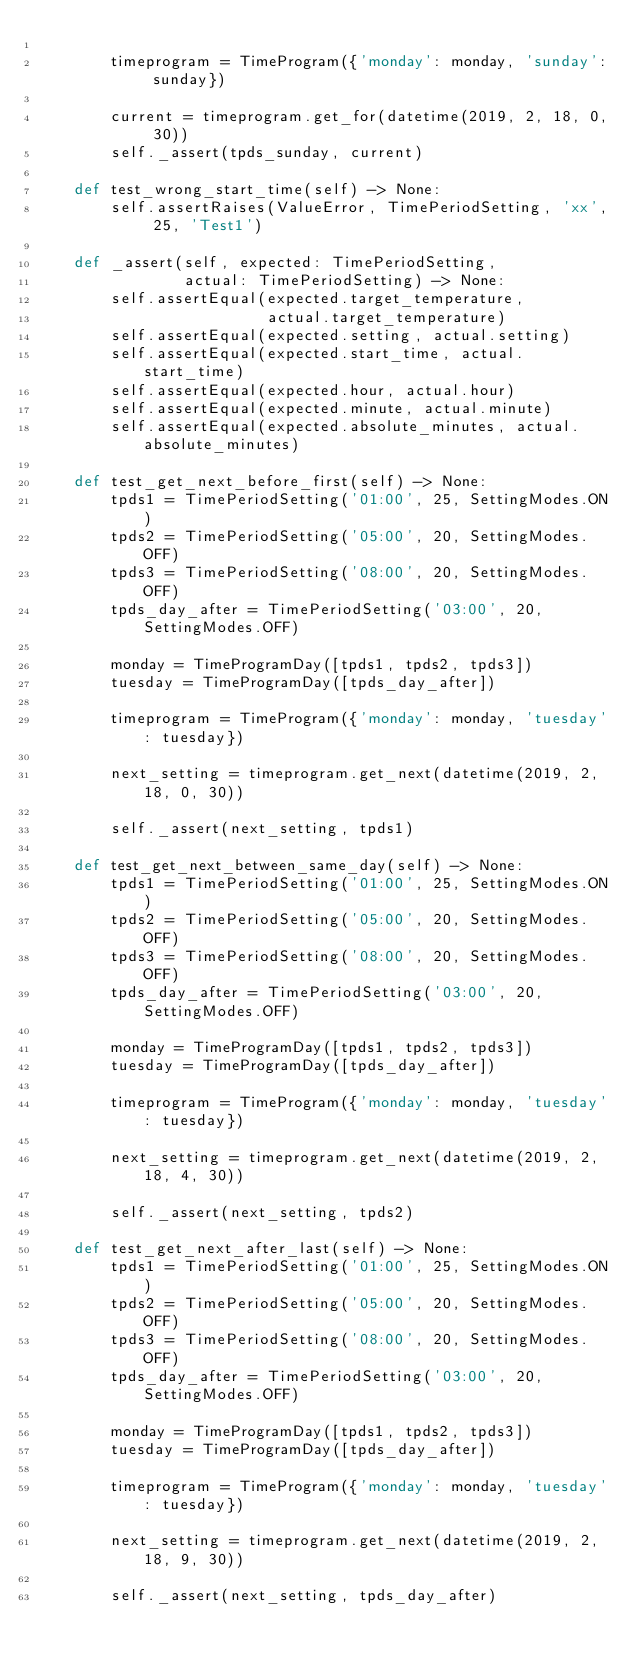Convert code to text. <code><loc_0><loc_0><loc_500><loc_500><_Python_>
        timeprogram = TimeProgram({'monday': monday, 'sunday': sunday})

        current = timeprogram.get_for(datetime(2019, 2, 18, 0, 30))
        self._assert(tpds_sunday, current)

    def test_wrong_start_time(self) -> None:
        self.assertRaises(ValueError, TimePeriodSetting, 'xx', 25, 'Test1')

    def _assert(self, expected: TimePeriodSetting,
                actual: TimePeriodSetting) -> None:
        self.assertEqual(expected.target_temperature,
                         actual.target_temperature)
        self.assertEqual(expected.setting, actual.setting)
        self.assertEqual(expected.start_time, actual.start_time)
        self.assertEqual(expected.hour, actual.hour)
        self.assertEqual(expected.minute, actual.minute)
        self.assertEqual(expected.absolute_minutes, actual.absolute_minutes)

    def test_get_next_before_first(self) -> None:
        tpds1 = TimePeriodSetting('01:00', 25, SettingModes.ON)
        tpds2 = TimePeriodSetting('05:00', 20, SettingModes.OFF)
        tpds3 = TimePeriodSetting('08:00', 20, SettingModes.OFF)
        tpds_day_after = TimePeriodSetting('03:00', 20, SettingModes.OFF)

        monday = TimeProgramDay([tpds1, tpds2, tpds3])
        tuesday = TimeProgramDay([tpds_day_after])

        timeprogram = TimeProgram({'monday': monday, 'tuesday': tuesday})

        next_setting = timeprogram.get_next(datetime(2019, 2, 18, 0, 30))

        self._assert(next_setting, tpds1)

    def test_get_next_between_same_day(self) -> None:
        tpds1 = TimePeriodSetting('01:00', 25, SettingModes.ON)
        tpds2 = TimePeriodSetting('05:00', 20, SettingModes.OFF)
        tpds3 = TimePeriodSetting('08:00', 20, SettingModes.OFF)
        tpds_day_after = TimePeriodSetting('03:00', 20, SettingModes.OFF)

        monday = TimeProgramDay([tpds1, tpds2, tpds3])
        tuesday = TimeProgramDay([tpds_day_after])

        timeprogram = TimeProgram({'monday': monday, 'tuesday': tuesday})

        next_setting = timeprogram.get_next(datetime(2019, 2, 18, 4, 30))

        self._assert(next_setting, tpds2)

    def test_get_next_after_last(self) -> None:
        tpds1 = TimePeriodSetting('01:00', 25, SettingModes.ON)
        tpds2 = TimePeriodSetting('05:00', 20, SettingModes.OFF)
        tpds3 = TimePeriodSetting('08:00', 20, SettingModes.OFF)
        tpds_day_after = TimePeriodSetting('03:00', 20, SettingModes.OFF)

        monday = TimeProgramDay([tpds1, tpds2, tpds3])
        tuesday = TimeProgramDay([tpds_day_after])

        timeprogram = TimeProgram({'monday': monday, 'tuesday': tuesday})

        next_setting = timeprogram.get_next(datetime(2019, 2, 18, 9, 30))

        self._assert(next_setting, tpds_day_after)
</code> 